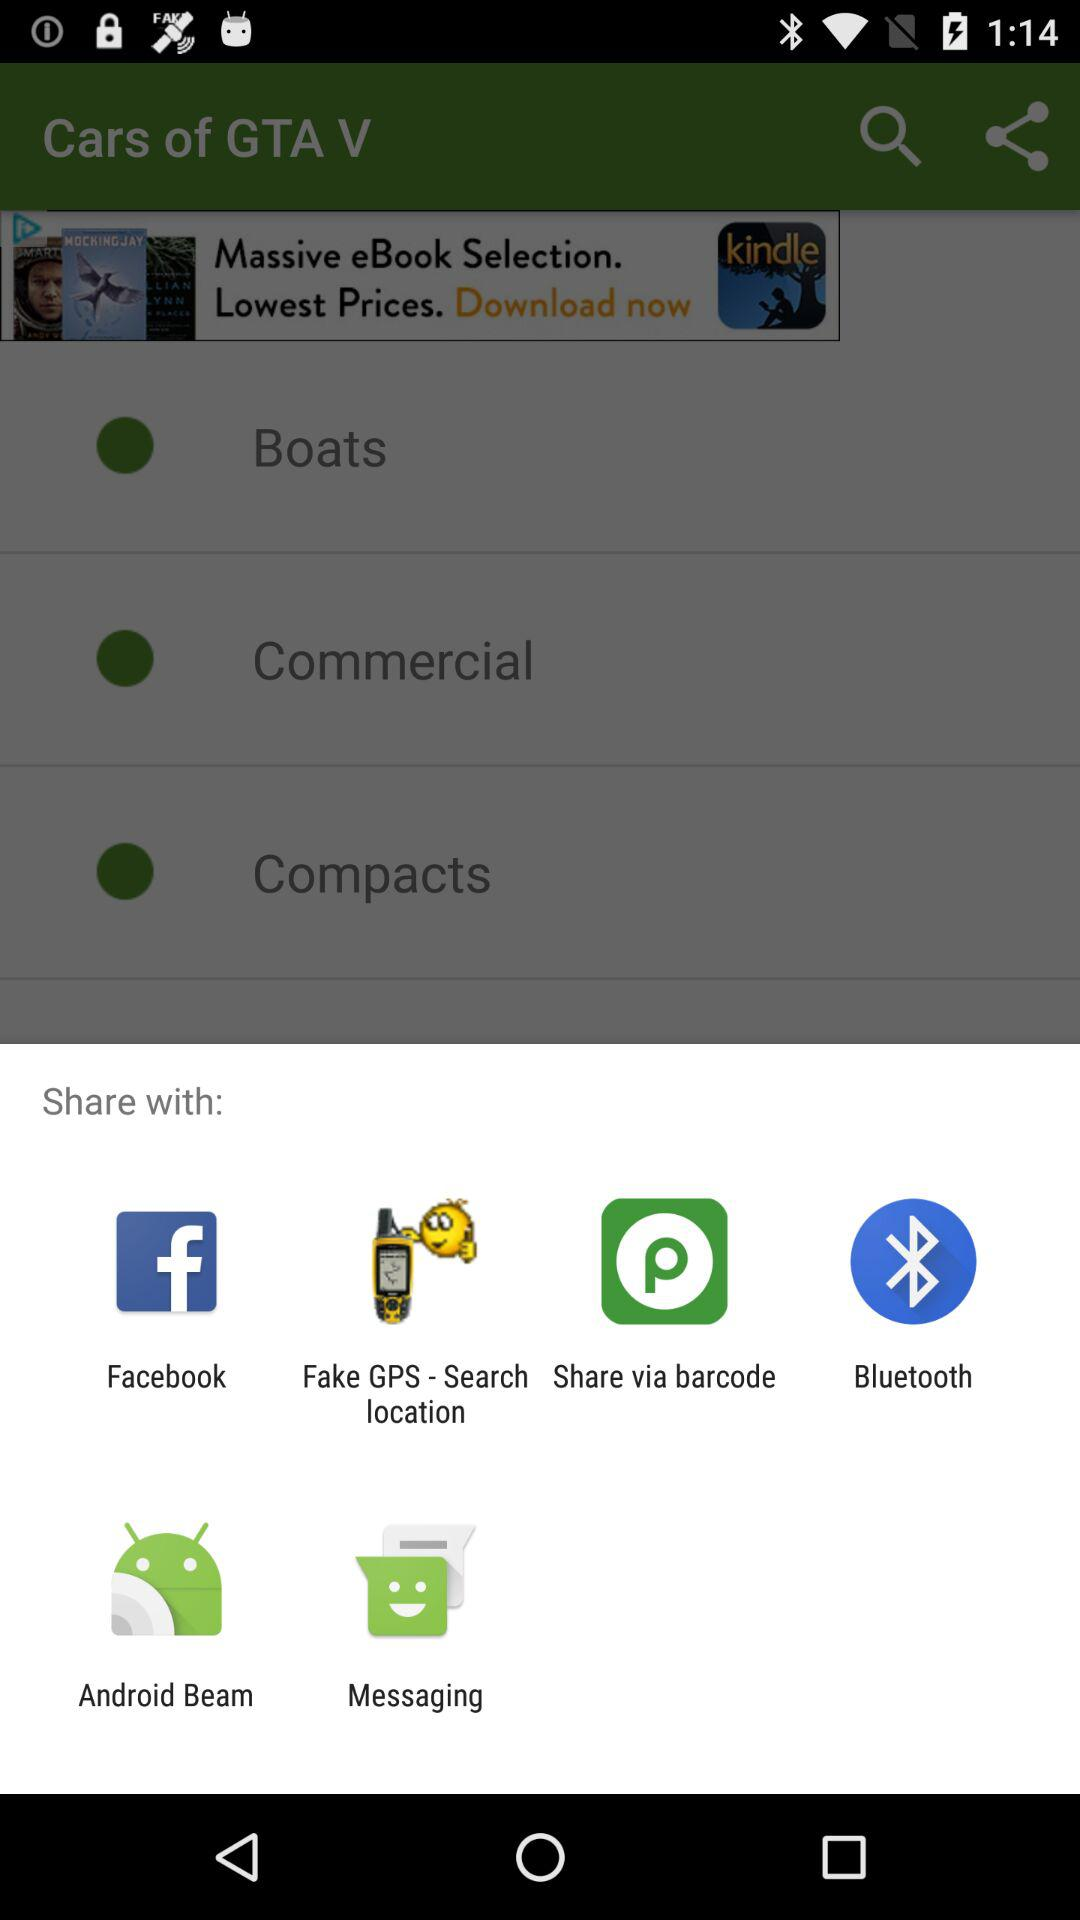What applications can be used to share? The applications that can be used to share are: "Facebook", "Fake GPS - Search location", "Share via barcode", "Bluetooth", "Android Beam", and "Messaging". 